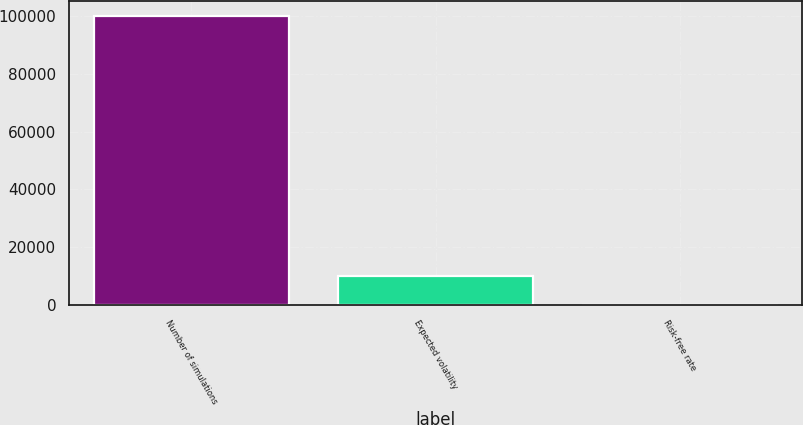Convert chart. <chart><loc_0><loc_0><loc_500><loc_500><bar_chart><fcel>Number of simulations<fcel>Expected volatility<fcel>Risk-free rate<nl><fcel>100000<fcel>10004<fcel>4.4<nl></chart> 